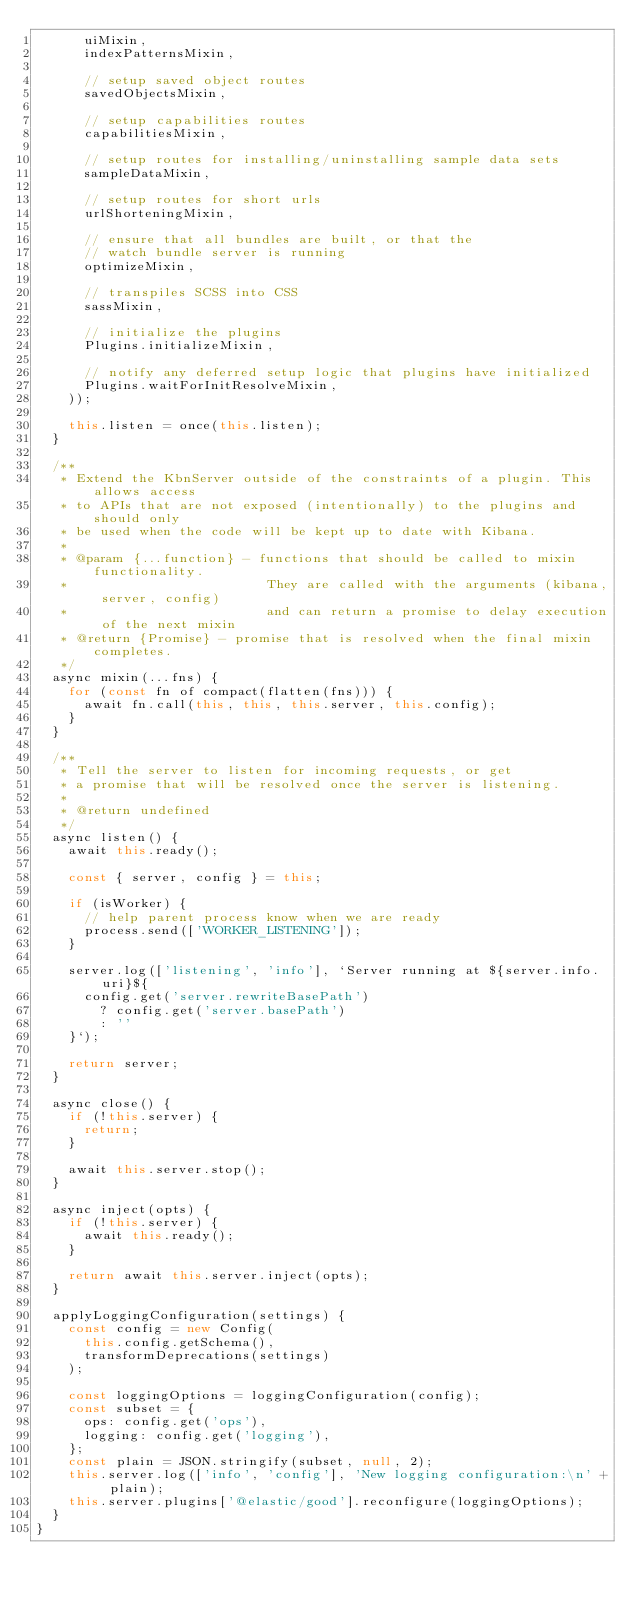Convert code to text. <code><loc_0><loc_0><loc_500><loc_500><_JavaScript_>      uiMixin,
      indexPatternsMixin,

      // setup saved object routes
      savedObjectsMixin,

      // setup capabilities routes
      capabilitiesMixin,

      // setup routes for installing/uninstalling sample data sets
      sampleDataMixin,

      // setup routes for short urls
      urlShorteningMixin,

      // ensure that all bundles are built, or that the
      // watch bundle server is running
      optimizeMixin,

      // transpiles SCSS into CSS
      sassMixin,

      // initialize the plugins
      Plugins.initializeMixin,

      // notify any deferred setup logic that plugins have initialized
      Plugins.waitForInitResolveMixin,
    ));

    this.listen = once(this.listen);
  }

  /**
   * Extend the KbnServer outside of the constraints of a plugin. This allows access
   * to APIs that are not exposed (intentionally) to the plugins and should only
   * be used when the code will be kept up to date with Kibana.
   *
   * @param {...function} - functions that should be called to mixin functionality.
   *                         They are called with the arguments (kibana, server, config)
   *                         and can return a promise to delay execution of the next mixin
   * @return {Promise} - promise that is resolved when the final mixin completes.
   */
  async mixin(...fns) {
    for (const fn of compact(flatten(fns))) {
      await fn.call(this, this, this.server, this.config);
    }
  }

  /**
   * Tell the server to listen for incoming requests, or get
   * a promise that will be resolved once the server is listening.
   *
   * @return undefined
   */
  async listen() {
    await this.ready();

    const { server, config } = this;

    if (isWorker) {
      // help parent process know when we are ready
      process.send(['WORKER_LISTENING']);
    }

    server.log(['listening', 'info'], `Server running at ${server.info.uri}${
      config.get('server.rewriteBasePath')
        ? config.get('server.basePath')
        : ''
    }`);

    return server;
  }

  async close() {
    if (!this.server) {
      return;
    }

    await this.server.stop();
  }

  async inject(opts) {
    if (!this.server) {
      await this.ready();
    }

    return await this.server.inject(opts);
  }

  applyLoggingConfiguration(settings) {
    const config = new Config(
      this.config.getSchema(),
      transformDeprecations(settings)
    );

    const loggingOptions = loggingConfiguration(config);
    const subset = {
      ops: config.get('ops'),
      logging: config.get('logging'),
    };
    const plain = JSON.stringify(subset, null, 2);
    this.server.log(['info', 'config'], 'New logging configuration:\n' + plain);
    this.server.plugins['@elastic/good'].reconfigure(loggingOptions);
  }
}
</code> 